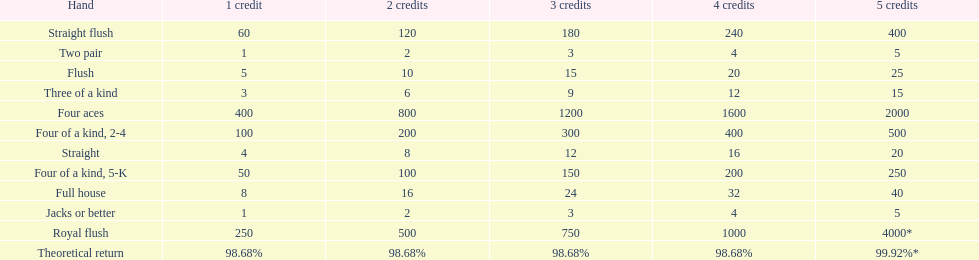At most, what could a person earn for having a full house? 40. 